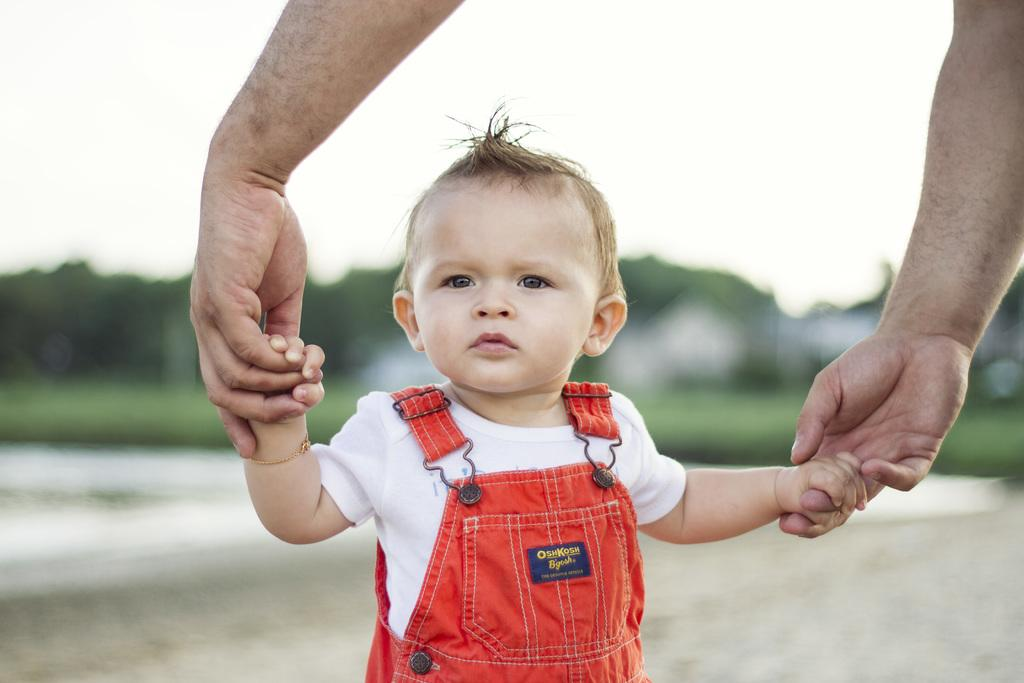What is happening between the person and the child in the image? The person is holding hands with a child in the image. What can be seen in the background of the image? The ground, trees, and sky are visible in the background of the image. Can you describe the quality of the image? The image is blurry. What type of fear is the child experiencing in the image? There is no indication of fear in the image; the child is simply holding hands with the person. Can you hear any bells ringing in the image? There is no sound present in the image, so it is not possible to hear any bells ringing. 